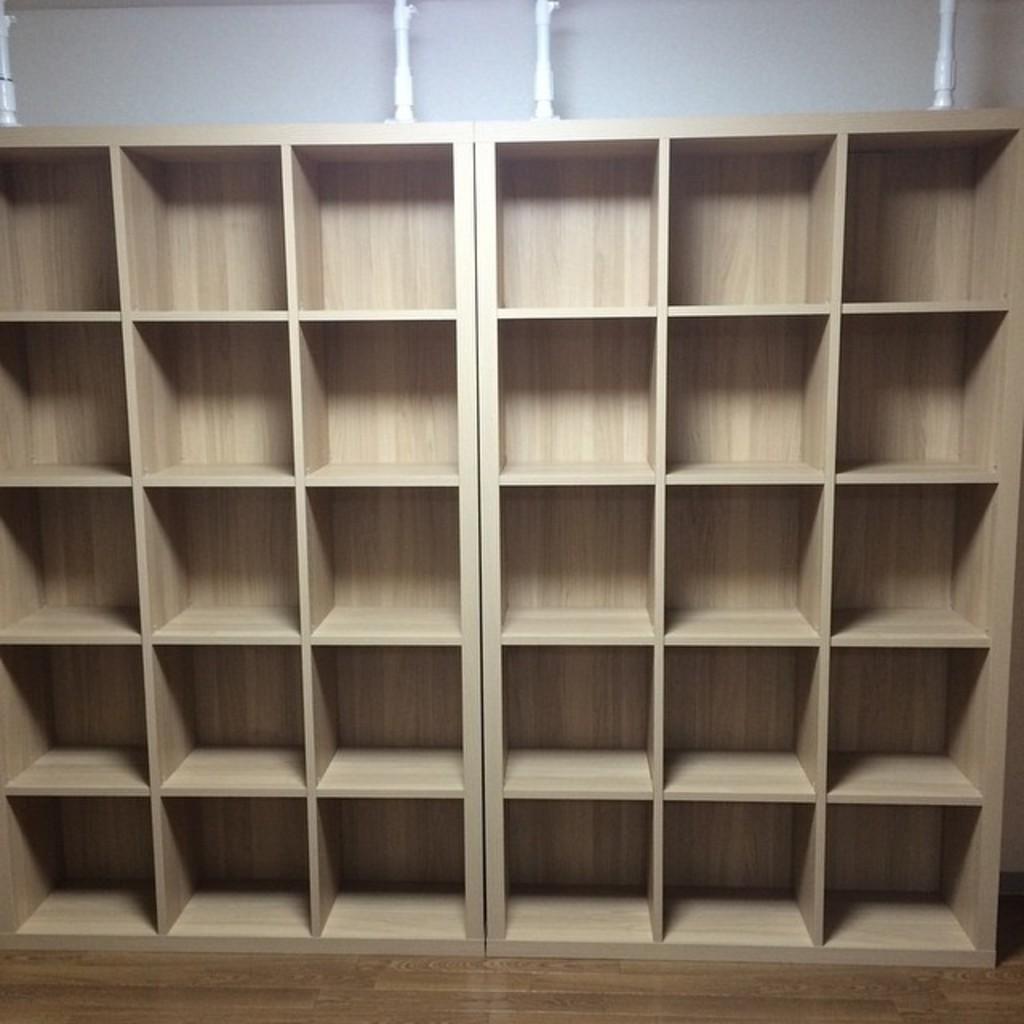Please provide a concise description of this image. In this picture we can see a few wooden shelves and some white objects are visible on top of the picture. 